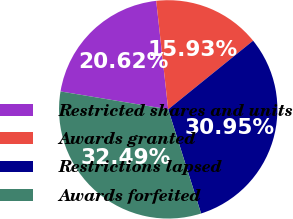<chart> <loc_0><loc_0><loc_500><loc_500><pie_chart><fcel>Restricted shares and units<fcel>Awards granted<fcel>Restrictions lapsed<fcel>Awards forfeited<nl><fcel>20.62%<fcel>15.93%<fcel>30.95%<fcel>32.49%<nl></chart> 